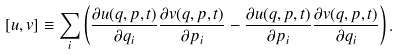Convert formula to latex. <formula><loc_0><loc_0><loc_500><loc_500>[ u , v ] \equiv \sum _ { i } \left ( \frac { \partial u ( q , p , t ) } { \partial q _ { i } } \frac { \partial v ( q , p , t ) } { \partial p _ { i } } - \frac { \partial u ( q , p , t ) } { \partial p _ { i } } \frac { \partial v ( q , p , t ) } { \partial q _ { i } } \right ) .</formula> 